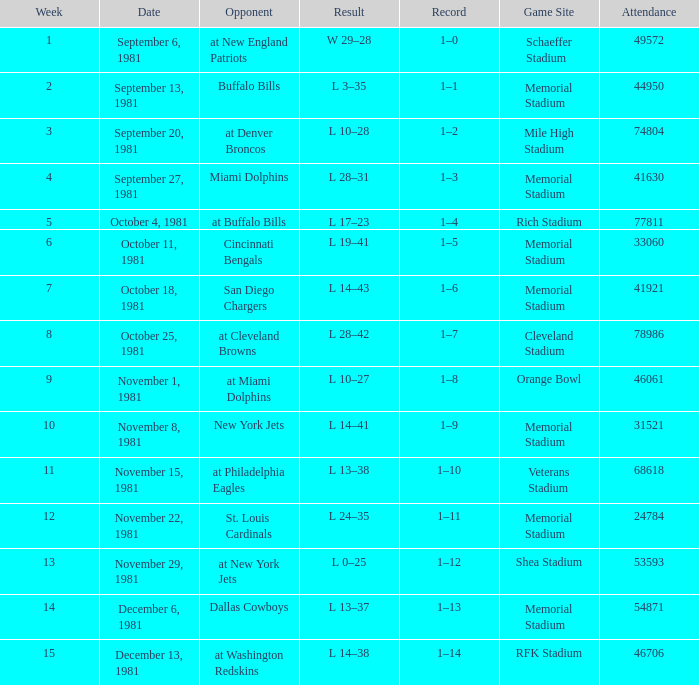Who is the rival on october 25, 1981? At cleveland browns. 